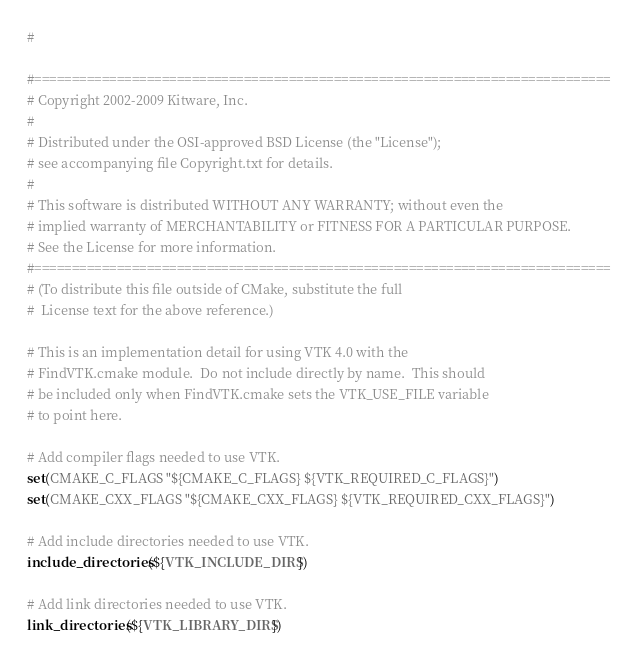Convert code to text. <code><loc_0><loc_0><loc_500><loc_500><_CMake_>#

#=============================================================================
# Copyright 2002-2009 Kitware, Inc.
#
# Distributed under the OSI-approved BSD License (the "License");
# see accompanying file Copyright.txt for details.
#
# This software is distributed WITHOUT ANY WARRANTY; without even the
# implied warranty of MERCHANTABILITY or FITNESS FOR A PARTICULAR PURPOSE.
# See the License for more information.
#=============================================================================
# (To distribute this file outside of CMake, substitute the full
#  License text for the above reference.)

# This is an implementation detail for using VTK 4.0 with the
# FindVTK.cmake module.  Do not include directly by name.  This should
# be included only when FindVTK.cmake sets the VTK_USE_FILE variable
# to point here.

# Add compiler flags needed to use VTK.
set(CMAKE_C_FLAGS "${CMAKE_C_FLAGS} ${VTK_REQUIRED_C_FLAGS}")
set(CMAKE_CXX_FLAGS "${CMAKE_CXX_FLAGS} ${VTK_REQUIRED_CXX_FLAGS}")

# Add include directories needed to use VTK.
include_directories(${VTK_INCLUDE_DIRS})

# Add link directories needed to use VTK.
link_directories(${VTK_LIBRARY_DIRS})
</code> 